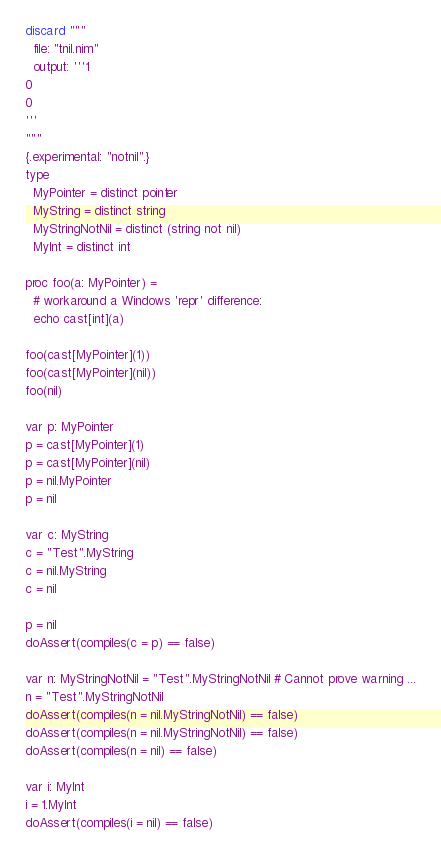<code> <loc_0><loc_0><loc_500><loc_500><_Nim_>discard """
  file: "tnil.nim"
  output: '''1
0
0
'''
"""
{.experimental: "notnil".}
type
  MyPointer = distinct pointer
  MyString = distinct string
  MyStringNotNil = distinct (string not nil)
  MyInt = distinct int

proc foo(a: MyPointer) =
  # workaround a Windows 'repr' difference:
  echo cast[int](a)

foo(cast[MyPointer](1))
foo(cast[MyPointer](nil))
foo(nil)

var p: MyPointer
p = cast[MyPointer](1)
p = cast[MyPointer](nil)
p = nil.MyPointer
p = nil

var c: MyString
c = "Test".MyString
c = nil.MyString
c = nil

p = nil
doAssert(compiles(c = p) == false)

var n: MyStringNotNil = "Test".MyStringNotNil # Cannot prove warning ...
n = "Test".MyStringNotNil
doAssert(compiles(n = nil.MyStringNotNil) == false)
doAssert(compiles(n = nil.MyStringNotNil) == false)
doAssert(compiles(n = nil) == false)

var i: MyInt
i = 1.MyInt
doAssert(compiles(i = nil) == false)
</code> 